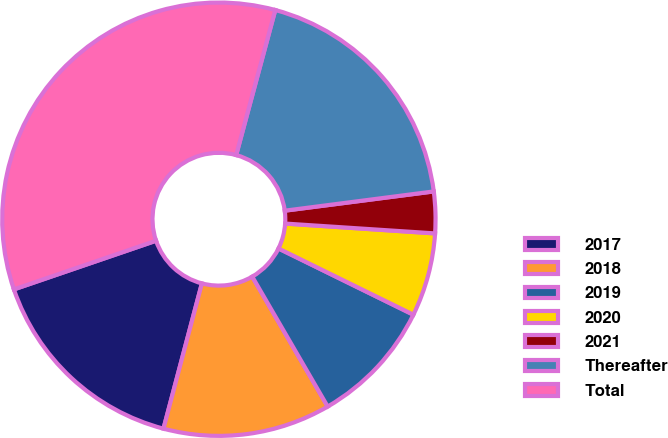<chart> <loc_0><loc_0><loc_500><loc_500><pie_chart><fcel>2017<fcel>2018<fcel>2019<fcel>2020<fcel>2021<fcel>Thereafter<fcel>Total<nl><fcel>15.63%<fcel>12.49%<fcel>9.36%<fcel>6.22%<fcel>3.09%<fcel>18.76%<fcel>34.44%<nl></chart> 